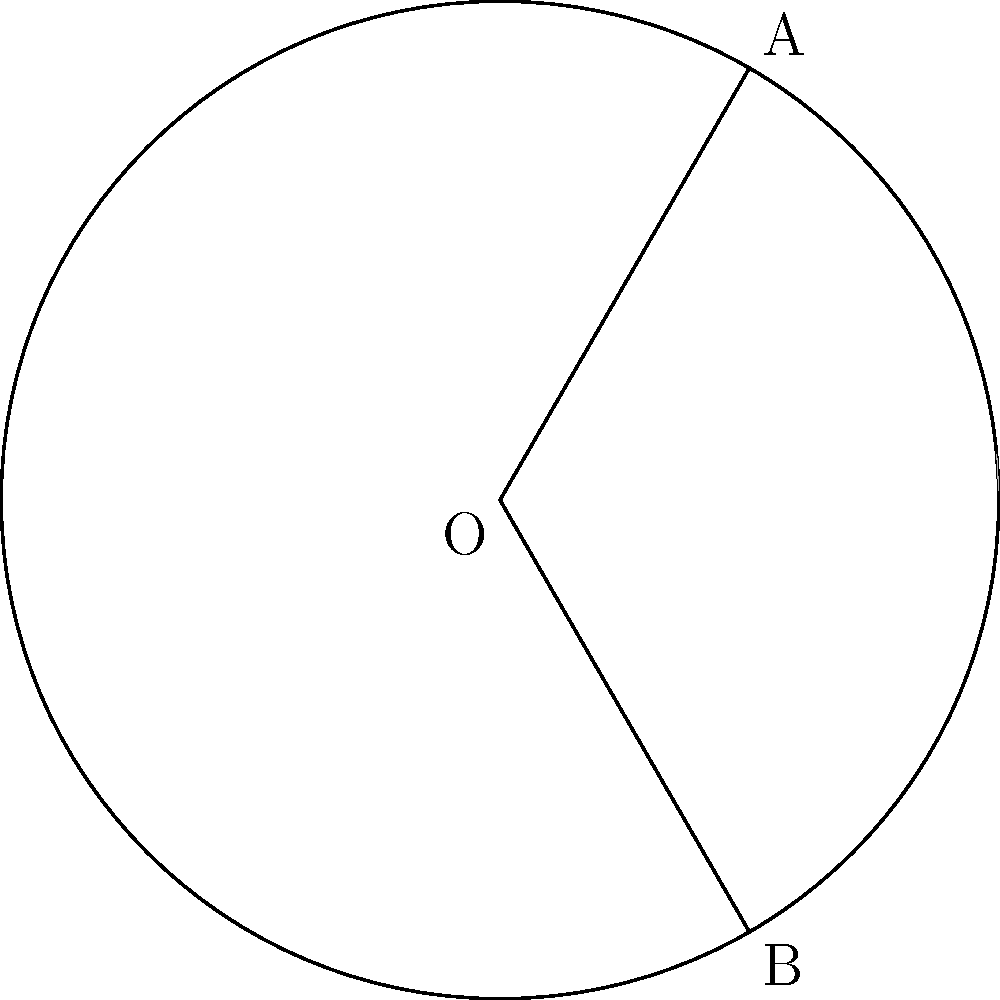In the circle above with center O and radius 3 units, points A and B are located on the circumference. The shaded region is bounded by the arc AB and the line segments OA and OB. If angle AOB is 240°, what is the area of the shaded region? Let's approach this step-by-step and discuss our method as we go along. Let's break this down into steps:

1) First, we need to calculate the area of the sector AOB:
   - The formula for the area of a sector is: $A_{sector} = \frac{\theta}{360°} \pi r^2$
   - Here, $\theta = 240°$ and $r = 3$
   - $A_{sector} = \frac{240}{360} \pi 3^2 = 6\pi$ square units

2) Next, we need to calculate the area of the triangle AOB:
   - The formula for the area of a triangle is: $A_{triangle} = \frac{1}{2}ab\sin C$
   - In our case, $a = b = 3$ (radius), and $C = 240°$
   - $A_{triangle} = \frac{1}{2} \cdot 3 \cdot 3 \cdot \sin 240°$
   - $\sin 240° = -\frac{\sqrt{3}}{2}$
   - $A_{triangle} = \frac{1}{2} \cdot 3 \cdot 3 \cdot (-\frac{\sqrt{3}}{2}) = -\frac{9\sqrt{3}}{4}$ square units

3) The shaded area is the difference between the sector area and the triangle area:
   $A_{shaded} = A_{sector} - A_{triangle}$
   $A_{shaded} = 6\pi - (-\frac{9\sqrt{3}}{4})$
   $A_{shaded} = 6\pi + \frac{9\sqrt{3}}{4}$ square units

This approach allows us to break down the problem into manageable steps and discuss the method as we progress, fitting well with a collaborative and iterative approach to problem-solving.
Answer: $6\pi + \frac{9\sqrt{3}}{4}$ square units 